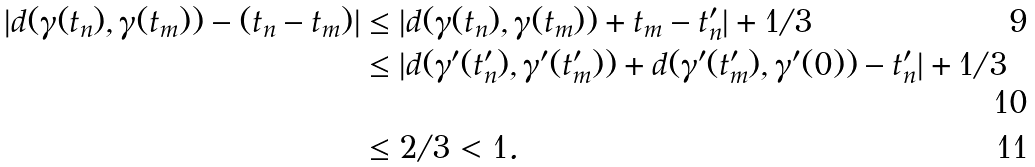Convert formula to latex. <formula><loc_0><loc_0><loc_500><loc_500>| d ( \gamma ( t _ { n } ) , \gamma ( t _ { m } ) ) - ( t _ { n } - t _ { m } ) | & \leq | d ( \gamma ( t _ { n } ) , \gamma ( t _ { m } ) ) + t _ { m } - t _ { n } ^ { \prime } | + 1 / 3 \\ & \leq | d ( \gamma ^ { \prime } ( t _ { n } ^ { \prime } ) , \gamma ^ { \prime } ( t _ { m } ^ { \prime } ) ) + d ( \gamma ^ { \prime } ( t _ { m } ^ { \prime } ) , \gamma ^ { \prime } ( 0 ) ) - t _ { n } ^ { \prime } | + 1 / 3 \\ & \leq 2 / 3 < 1 .</formula> 